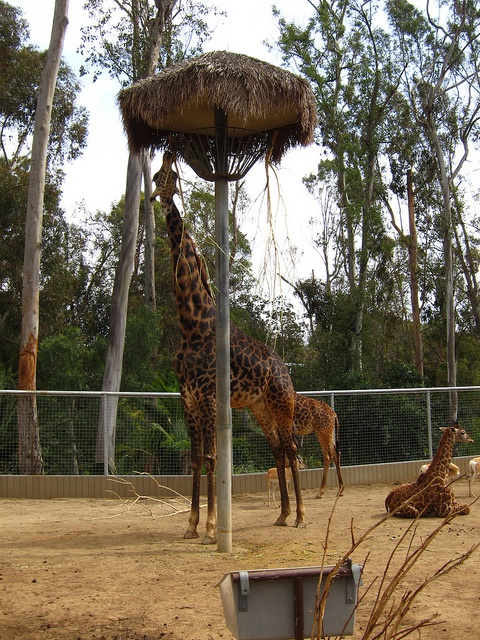Describe the objects in this image and their specific colors. I can see giraffe in darkgray, black, maroon, and gray tones, giraffe in darkgray, maroon, black, and olive tones, and giraffe in darkgray, maroon, black, and brown tones in this image. 